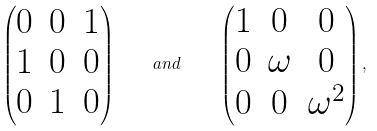<formula> <loc_0><loc_0><loc_500><loc_500>\begin{pmatrix} 0 & 0 & 1 \\ 1 & 0 & 0 \\ 0 & 1 & 0 \end{pmatrix} \quad a n d \quad \begin{pmatrix} 1 & 0 & 0 \\ 0 & \omega & 0 \\ 0 & 0 & \omega ^ { 2 } \end{pmatrix} ,</formula> 